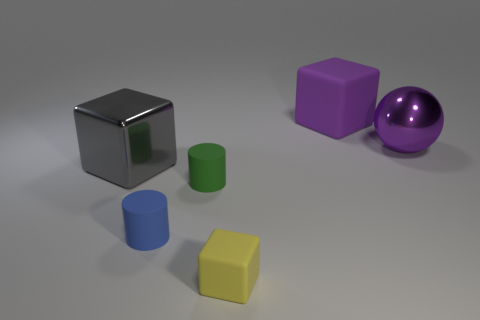Subtract all big blocks. How many blocks are left? 1 Add 3 tiny blue matte cylinders. How many objects exist? 9 Subtract all green cylinders. How many cylinders are left? 1 Subtract all balls. How many objects are left? 5 Subtract 1 spheres. How many spheres are left? 0 Subtract all big purple matte objects. Subtract all big balls. How many objects are left? 4 Add 2 gray blocks. How many gray blocks are left? 3 Add 1 small green rubber cylinders. How many small green rubber cylinders exist? 2 Subtract 0 blue blocks. How many objects are left? 6 Subtract all red blocks. Subtract all cyan cylinders. How many blocks are left? 3 